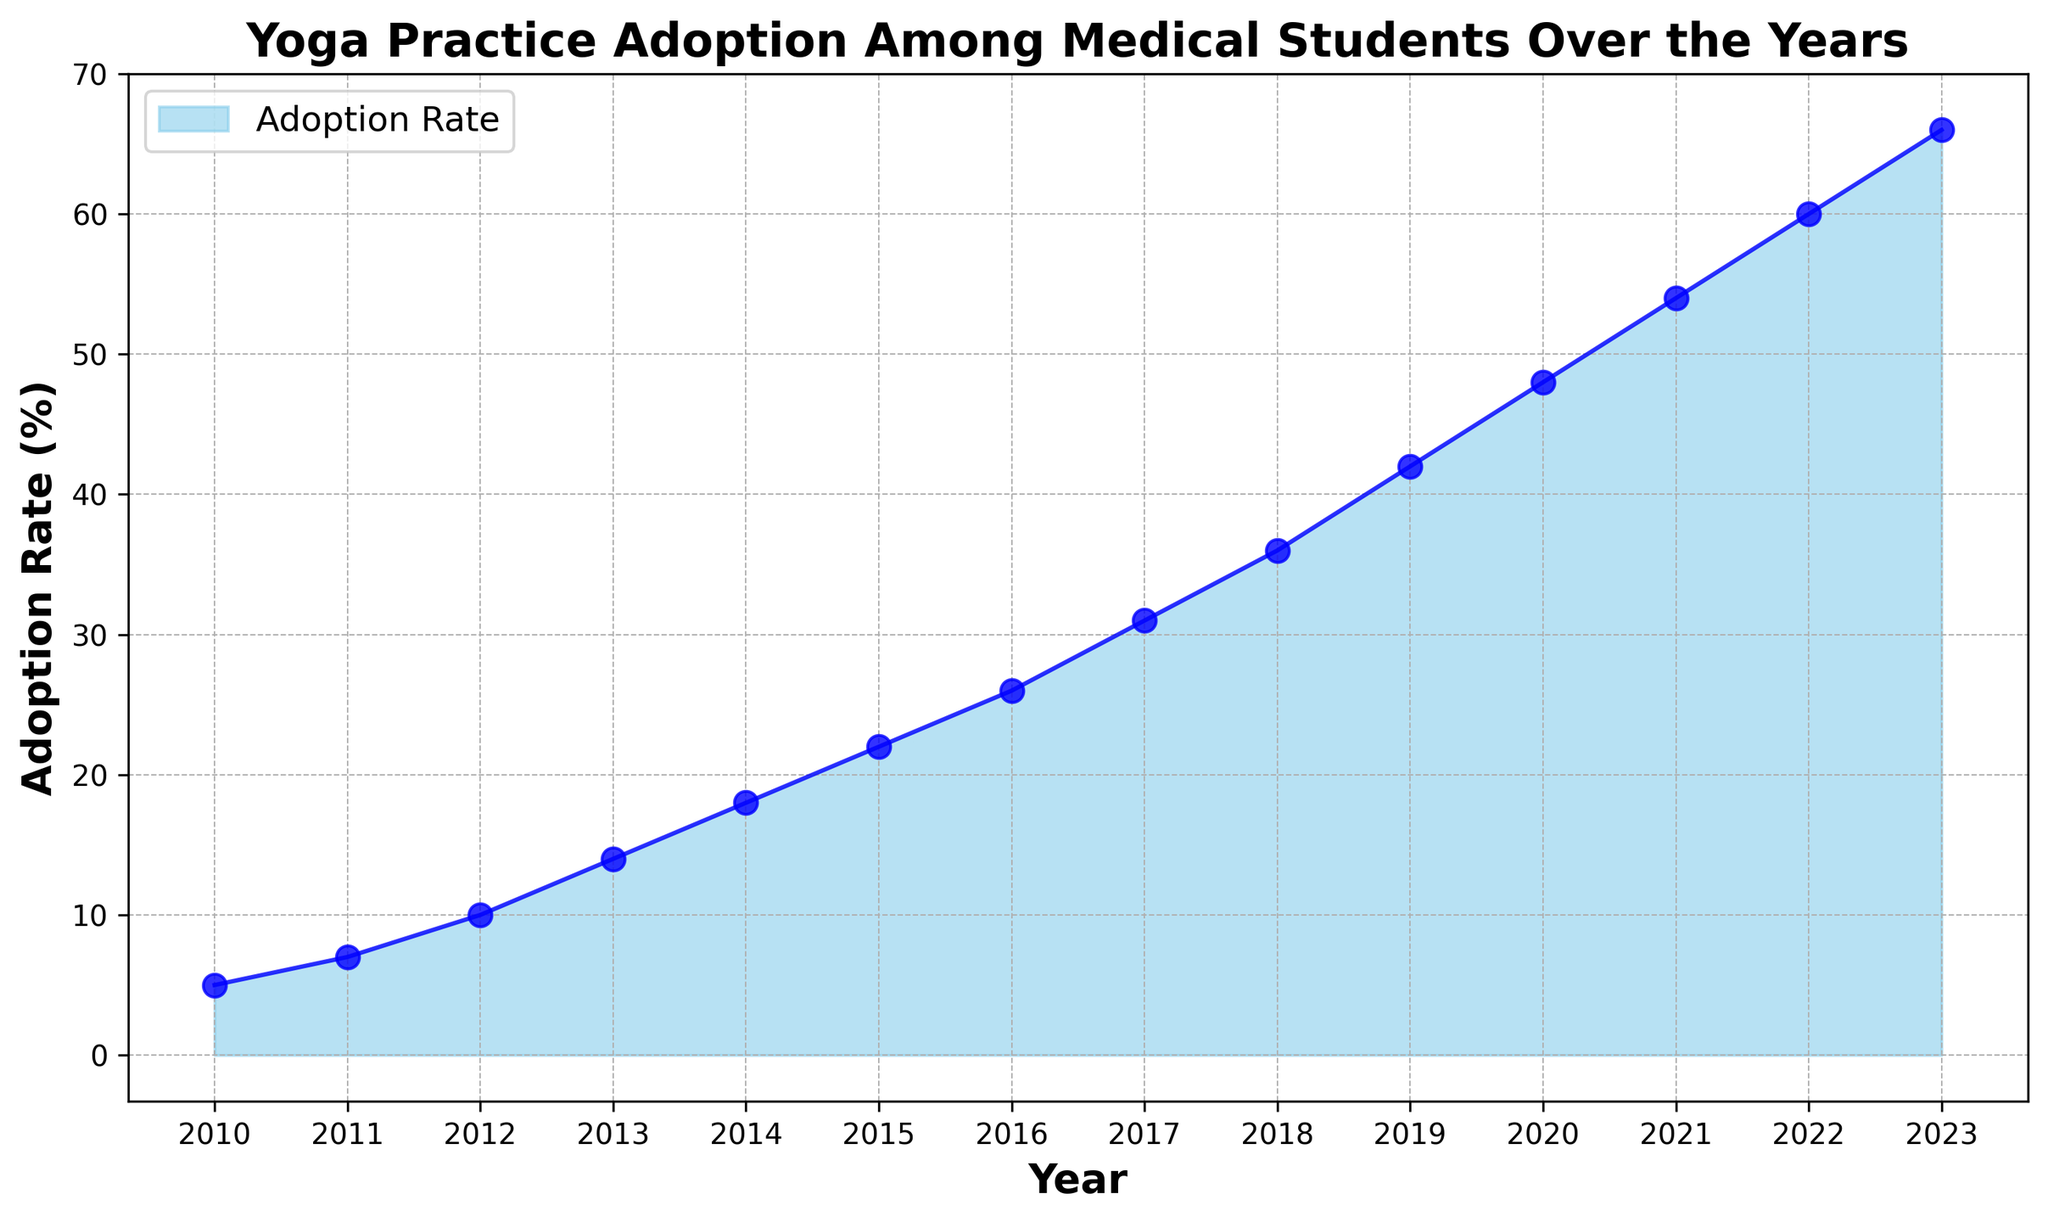What's the adoption rate in 2015? Locate the year 2015 on the x-axis and trace it upwards to the corresponding point on the graph, and then follow it horizontally to the y-axis to read the adoption rate.
Answer: 22% In which year did the adoption rate reach 54%? Locate the 54% mark on the y-axis and trace it horizontally until it intersects with the plotted line, then follow it vertically downwards to determine the year on the x-axis.
Answer: 2021 What is the difference in adoption rates between 2010 and 2020? Find the adoption rates for 2010 and 2020 on the graph. For 2010, it's 5%, and for 2020, it's 48%. Subtract the value for 2010 from the value for 2020. 48% - 5% = 43%.
Answer: 43% What was the average adoption rate from 2018 to 2023? Find the adoption rates for each year from 2018 to 2023 and sum them up: 36% + 42% + 48% + 54% + 60% + 66% = 306%. Then divide the sum by the number of years (6). 306% / 6 = 51%.
Answer: 51% Between which two consecutive years did the adoption rate increase the most? Calculate the differences in adoption rates for each pair of consecutive years and identify the largest difference:
2011 - 2010 = 7% - 5% = 2%
2012 - 2011 = 10% - 7% = 3%
2013 - 2012 = 14% - 10% = 4%
2014 - 2013 = 18% - 14% = 4%
2015 - 2014 = 22% - 18% = 4%
2016 - 2015 = 26% - 22% = 4%
2017 - 2016 = 31% - 26% = 5%
2018 - 2017 = 36% - 31% = 5%
2019 - 2018 = 42% - 36% = 6%
2020 - 2019 = 48% - 42% = 6%
2021 - 2020 = 54% - 48% = 6%
2022 - 2021 = 60% - 54% = 6%
2023 - 2022 = 66% - 60% = 6%
The largest increase occurred between any of these pairs (2019-2020, 2020-2021, 2021-2022, 2022-2023), all with an increase of 6%.
Answer: 2019-2020 (or 2020-2021, or 2021-2022, or 2022-2023) What is the trend in yoga practice adoption among medical students between 2010 and 2023? Observe the overall direction of the plotted line from the starting year (2010) to the ending year (2023). The line shows a consistent upward trend as the adoption rate increases each year.
Answer: Increasing 